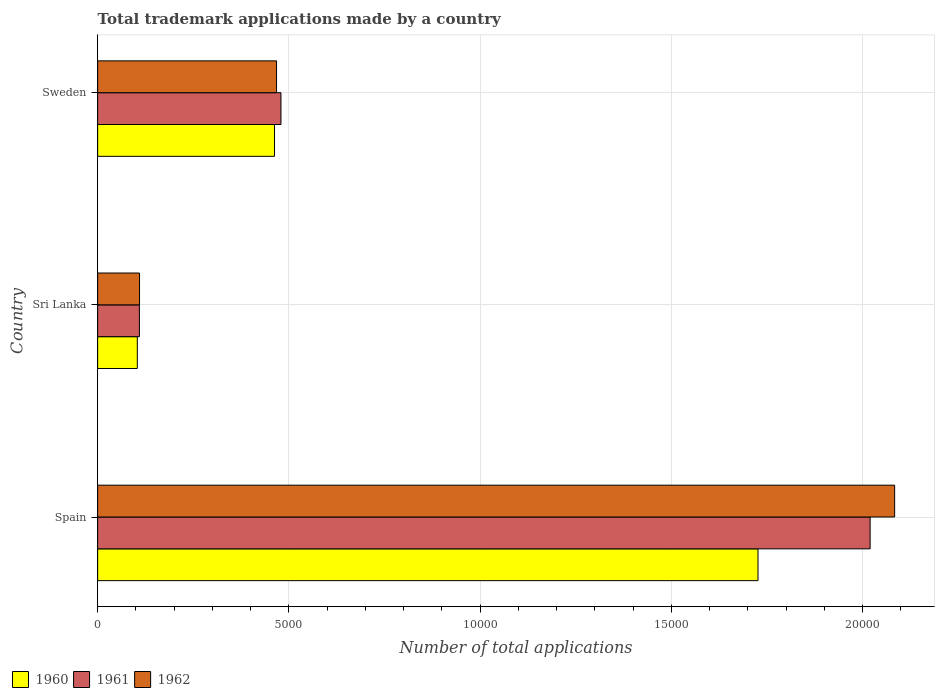How many groups of bars are there?
Your answer should be compact. 3. How many bars are there on the 1st tick from the top?
Keep it short and to the point. 3. What is the label of the 2nd group of bars from the top?
Provide a succinct answer. Sri Lanka. In how many cases, is the number of bars for a given country not equal to the number of legend labels?
Provide a short and direct response. 0. What is the number of applications made by in 1960 in Sri Lanka?
Offer a terse response. 1037. Across all countries, what is the maximum number of applications made by in 1962?
Give a very brief answer. 2.08e+04. Across all countries, what is the minimum number of applications made by in 1962?
Provide a succinct answer. 1095. In which country was the number of applications made by in 1960 maximum?
Make the answer very short. Spain. In which country was the number of applications made by in 1961 minimum?
Offer a very short reply. Sri Lanka. What is the total number of applications made by in 1962 in the graph?
Your response must be concise. 2.66e+04. What is the difference between the number of applications made by in 1960 in Spain and that in Sri Lanka?
Give a very brief answer. 1.62e+04. What is the difference between the number of applications made by in 1962 in Sri Lanka and the number of applications made by in 1960 in Spain?
Provide a succinct answer. -1.62e+04. What is the average number of applications made by in 1962 per country?
Your answer should be very brief. 8869. What is the difference between the number of applications made by in 1961 and number of applications made by in 1962 in Sweden?
Make the answer very short. 115. In how many countries, is the number of applications made by in 1961 greater than 11000 ?
Your answer should be compact. 1. What is the ratio of the number of applications made by in 1961 in Spain to that in Sri Lanka?
Your answer should be very brief. 18.49. What is the difference between the highest and the second highest number of applications made by in 1962?
Your answer should be compact. 1.62e+04. What is the difference between the highest and the lowest number of applications made by in 1962?
Make the answer very short. 1.97e+04. Is the sum of the number of applications made by in 1960 in Sri Lanka and Sweden greater than the maximum number of applications made by in 1962 across all countries?
Give a very brief answer. No. What does the 1st bar from the top in Sweden represents?
Offer a terse response. 1962. What does the 3rd bar from the bottom in Sri Lanka represents?
Your response must be concise. 1962. Are the values on the major ticks of X-axis written in scientific E-notation?
Offer a very short reply. No. Where does the legend appear in the graph?
Keep it short and to the point. Bottom left. How many legend labels are there?
Provide a succinct answer. 3. What is the title of the graph?
Your answer should be very brief. Total trademark applications made by a country. Does "1979" appear as one of the legend labels in the graph?
Make the answer very short. No. What is the label or title of the X-axis?
Offer a terse response. Number of total applications. What is the label or title of the Y-axis?
Keep it short and to the point. Country. What is the Number of total applications in 1960 in Spain?
Your response must be concise. 1.73e+04. What is the Number of total applications of 1961 in Spain?
Give a very brief answer. 2.02e+04. What is the Number of total applications in 1962 in Spain?
Provide a succinct answer. 2.08e+04. What is the Number of total applications in 1960 in Sri Lanka?
Your answer should be compact. 1037. What is the Number of total applications in 1961 in Sri Lanka?
Ensure brevity in your answer.  1092. What is the Number of total applications in 1962 in Sri Lanka?
Ensure brevity in your answer.  1095. What is the Number of total applications in 1960 in Sweden?
Provide a succinct answer. 4624. What is the Number of total applications of 1961 in Sweden?
Your response must be concise. 4792. What is the Number of total applications in 1962 in Sweden?
Offer a terse response. 4677. Across all countries, what is the maximum Number of total applications in 1960?
Your answer should be compact. 1.73e+04. Across all countries, what is the maximum Number of total applications in 1961?
Your answer should be compact. 2.02e+04. Across all countries, what is the maximum Number of total applications in 1962?
Provide a short and direct response. 2.08e+04. Across all countries, what is the minimum Number of total applications of 1960?
Provide a succinct answer. 1037. Across all countries, what is the minimum Number of total applications in 1961?
Provide a short and direct response. 1092. Across all countries, what is the minimum Number of total applications of 1962?
Your answer should be compact. 1095. What is the total Number of total applications in 1960 in the graph?
Give a very brief answer. 2.29e+04. What is the total Number of total applications in 1961 in the graph?
Ensure brevity in your answer.  2.61e+04. What is the total Number of total applications in 1962 in the graph?
Ensure brevity in your answer.  2.66e+04. What is the difference between the Number of total applications in 1960 in Spain and that in Sri Lanka?
Give a very brief answer. 1.62e+04. What is the difference between the Number of total applications of 1961 in Spain and that in Sri Lanka?
Provide a succinct answer. 1.91e+04. What is the difference between the Number of total applications in 1962 in Spain and that in Sri Lanka?
Your answer should be compact. 1.97e+04. What is the difference between the Number of total applications of 1960 in Spain and that in Sweden?
Give a very brief answer. 1.26e+04. What is the difference between the Number of total applications of 1961 in Spain and that in Sweden?
Your answer should be compact. 1.54e+04. What is the difference between the Number of total applications in 1962 in Spain and that in Sweden?
Offer a very short reply. 1.62e+04. What is the difference between the Number of total applications in 1960 in Sri Lanka and that in Sweden?
Your answer should be very brief. -3587. What is the difference between the Number of total applications in 1961 in Sri Lanka and that in Sweden?
Provide a succinct answer. -3700. What is the difference between the Number of total applications in 1962 in Sri Lanka and that in Sweden?
Offer a very short reply. -3582. What is the difference between the Number of total applications of 1960 in Spain and the Number of total applications of 1961 in Sri Lanka?
Offer a very short reply. 1.62e+04. What is the difference between the Number of total applications in 1960 in Spain and the Number of total applications in 1962 in Sri Lanka?
Give a very brief answer. 1.62e+04. What is the difference between the Number of total applications of 1961 in Spain and the Number of total applications of 1962 in Sri Lanka?
Your answer should be compact. 1.91e+04. What is the difference between the Number of total applications in 1960 in Spain and the Number of total applications in 1961 in Sweden?
Make the answer very short. 1.25e+04. What is the difference between the Number of total applications of 1960 in Spain and the Number of total applications of 1962 in Sweden?
Your response must be concise. 1.26e+04. What is the difference between the Number of total applications in 1961 in Spain and the Number of total applications in 1962 in Sweden?
Provide a short and direct response. 1.55e+04. What is the difference between the Number of total applications of 1960 in Sri Lanka and the Number of total applications of 1961 in Sweden?
Your response must be concise. -3755. What is the difference between the Number of total applications of 1960 in Sri Lanka and the Number of total applications of 1962 in Sweden?
Ensure brevity in your answer.  -3640. What is the difference between the Number of total applications of 1961 in Sri Lanka and the Number of total applications of 1962 in Sweden?
Provide a short and direct response. -3585. What is the average Number of total applications in 1960 per country?
Your answer should be compact. 7641.33. What is the average Number of total applications of 1961 per country?
Give a very brief answer. 8692.67. What is the average Number of total applications of 1962 per country?
Your response must be concise. 8869. What is the difference between the Number of total applications in 1960 and Number of total applications in 1961 in Spain?
Offer a terse response. -2931. What is the difference between the Number of total applications in 1960 and Number of total applications in 1962 in Spain?
Provide a short and direct response. -3572. What is the difference between the Number of total applications of 1961 and Number of total applications of 1962 in Spain?
Your answer should be very brief. -641. What is the difference between the Number of total applications of 1960 and Number of total applications of 1961 in Sri Lanka?
Provide a succinct answer. -55. What is the difference between the Number of total applications in 1960 and Number of total applications in 1962 in Sri Lanka?
Offer a terse response. -58. What is the difference between the Number of total applications in 1960 and Number of total applications in 1961 in Sweden?
Provide a short and direct response. -168. What is the difference between the Number of total applications of 1960 and Number of total applications of 1962 in Sweden?
Your answer should be compact. -53. What is the difference between the Number of total applications of 1961 and Number of total applications of 1962 in Sweden?
Give a very brief answer. 115. What is the ratio of the Number of total applications of 1960 in Spain to that in Sri Lanka?
Offer a very short reply. 16.65. What is the ratio of the Number of total applications of 1961 in Spain to that in Sri Lanka?
Ensure brevity in your answer.  18.49. What is the ratio of the Number of total applications in 1962 in Spain to that in Sri Lanka?
Provide a short and direct response. 19.03. What is the ratio of the Number of total applications in 1960 in Spain to that in Sweden?
Your answer should be compact. 3.73. What is the ratio of the Number of total applications in 1961 in Spain to that in Sweden?
Your response must be concise. 4.21. What is the ratio of the Number of total applications in 1962 in Spain to that in Sweden?
Make the answer very short. 4.45. What is the ratio of the Number of total applications in 1960 in Sri Lanka to that in Sweden?
Your response must be concise. 0.22. What is the ratio of the Number of total applications of 1961 in Sri Lanka to that in Sweden?
Your answer should be compact. 0.23. What is the ratio of the Number of total applications of 1962 in Sri Lanka to that in Sweden?
Make the answer very short. 0.23. What is the difference between the highest and the second highest Number of total applications of 1960?
Offer a terse response. 1.26e+04. What is the difference between the highest and the second highest Number of total applications in 1961?
Your answer should be very brief. 1.54e+04. What is the difference between the highest and the second highest Number of total applications of 1962?
Your answer should be compact. 1.62e+04. What is the difference between the highest and the lowest Number of total applications in 1960?
Make the answer very short. 1.62e+04. What is the difference between the highest and the lowest Number of total applications of 1961?
Keep it short and to the point. 1.91e+04. What is the difference between the highest and the lowest Number of total applications in 1962?
Give a very brief answer. 1.97e+04. 